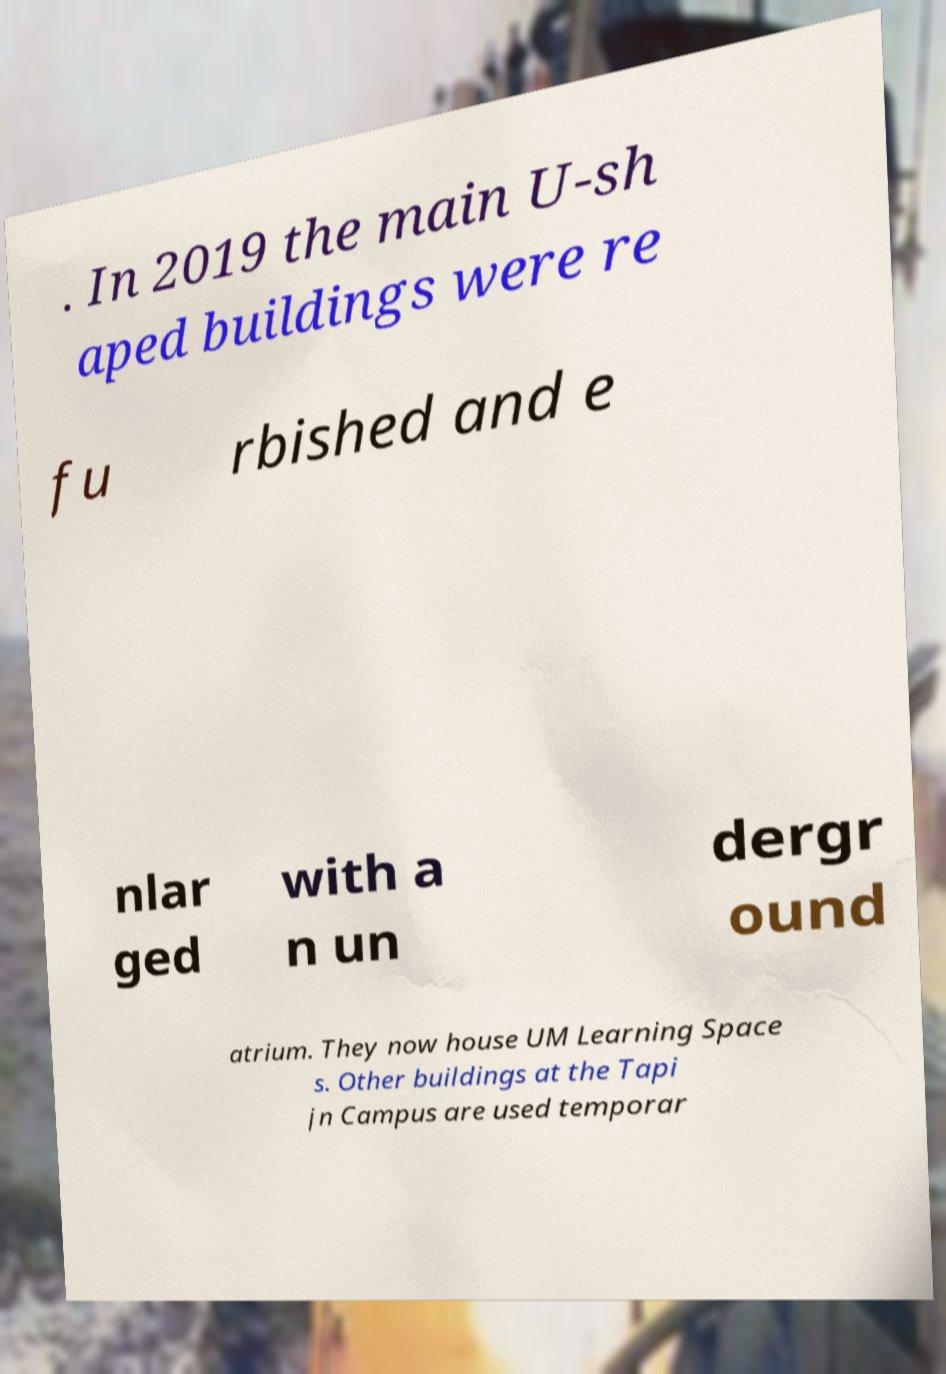Could you extract and type out the text from this image? . In 2019 the main U-sh aped buildings were re fu rbished and e nlar ged with a n un dergr ound atrium. They now house UM Learning Space s. Other buildings at the Tapi jn Campus are used temporar 